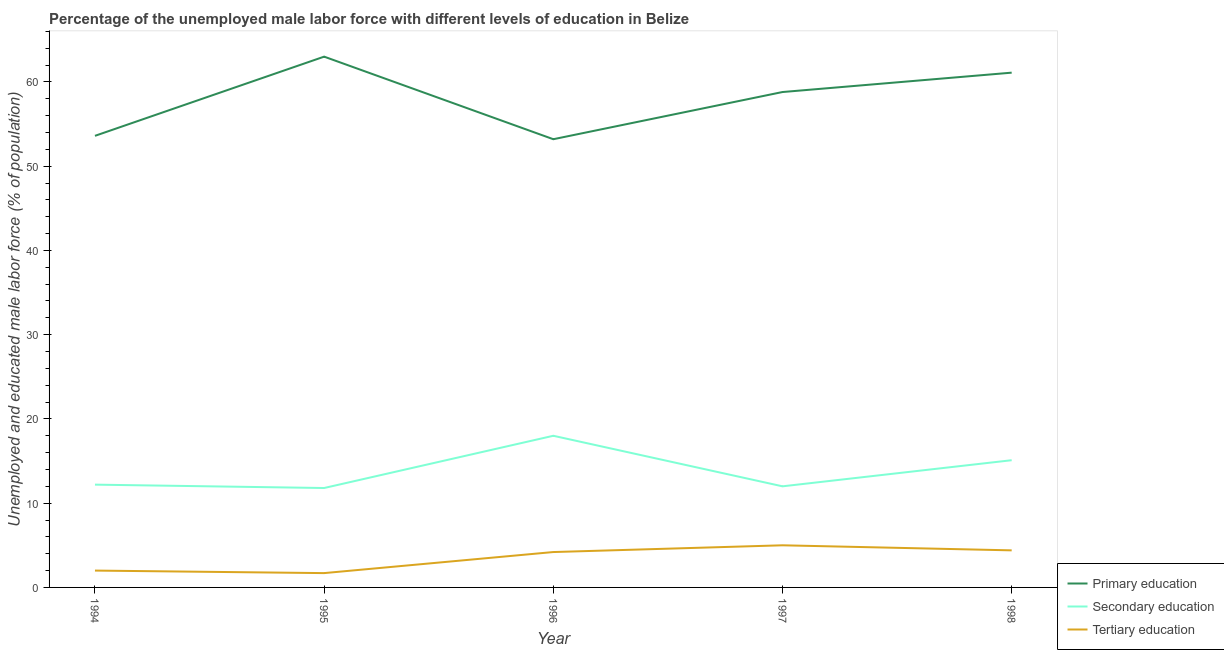What is the percentage of male labor force who received tertiary education in 1996?
Your answer should be compact. 4.2. Across all years, what is the minimum percentage of male labor force who received primary education?
Offer a terse response. 53.2. What is the total percentage of male labor force who received tertiary education in the graph?
Offer a terse response. 17.3. What is the difference between the percentage of male labor force who received primary education in 1995 and that in 1997?
Provide a short and direct response. 4.2. What is the difference between the percentage of male labor force who received tertiary education in 1997 and the percentage of male labor force who received primary education in 1995?
Your response must be concise. -58. What is the average percentage of male labor force who received primary education per year?
Give a very brief answer. 57.94. In the year 1995, what is the difference between the percentage of male labor force who received tertiary education and percentage of male labor force who received primary education?
Your answer should be compact. -61.3. In how many years, is the percentage of male labor force who received secondary education greater than 4 %?
Provide a succinct answer. 5. What is the ratio of the percentage of male labor force who received primary education in 1994 to that in 1997?
Keep it short and to the point. 0.91. Is the difference between the percentage of male labor force who received secondary education in 1996 and 1998 greater than the difference between the percentage of male labor force who received tertiary education in 1996 and 1998?
Offer a terse response. Yes. What is the difference between the highest and the second highest percentage of male labor force who received primary education?
Ensure brevity in your answer.  1.9. What is the difference between the highest and the lowest percentage of male labor force who received primary education?
Your response must be concise. 9.8. Is the sum of the percentage of male labor force who received primary education in 1995 and 1998 greater than the maximum percentage of male labor force who received tertiary education across all years?
Your answer should be compact. Yes. Is the percentage of male labor force who received secondary education strictly less than the percentage of male labor force who received tertiary education over the years?
Make the answer very short. No. How many years are there in the graph?
Provide a short and direct response. 5. What is the difference between two consecutive major ticks on the Y-axis?
Your answer should be very brief. 10. Are the values on the major ticks of Y-axis written in scientific E-notation?
Provide a short and direct response. No. Where does the legend appear in the graph?
Your response must be concise. Bottom right. How are the legend labels stacked?
Offer a very short reply. Vertical. What is the title of the graph?
Offer a terse response. Percentage of the unemployed male labor force with different levels of education in Belize. What is the label or title of the X-axis?
Keep it short and to the point. Year. What is the label or title of the Y-axis?
Provide a succinct answer. Unemployed and educated male labor force (% of population). What is the Unemployed and educated male labor force (% of population) of Primary education in 1994?
Make the answer very short. 53.6. What is the Unemployed and educated male labor force (% of population) of Secondary education in 1994?
Your answer should be very brief. 12.2. What is the Unemployed and educated male labor force (% of population) in Secondary education in 1995?
Provide a succinct answer. 11.8. What is the Unemployed and educated male labor force (% of population) in Tertiary education in 1995?
Your response must be concise. 1.7. What is the Unemployed and educated male labor force (% of population) of Primary education in 1996?
Provide a succinct answer. 53.2. What is the Unemployed and educated male labor force (% of population) in Tertiary education in 1996?
Your answer should be very brief. 4.2. What is the Unemployed and educated male labor force (% of population) in Primary education in 1997?
Ensure brevity in your answer.  58.8. What is the Unemployed and educated male labor force (% of population) of Secondary education in 1997?
Make the answer very short. 12. What is the Unemployed and educated male labor force (% of population) in Primary education in 1998?
Offer a terse response. 61.1. What is the Unemployed and educated male labor force (% of population) in Secondary education in 1998?
Your answer should be compact. 15.1. What is the Unemployed and educated male labor force (% of population) of Tertiary education in 1998?
Your answer should be compact. 4.4. Across all years, what is the maximum Unemployed and educated male labor force (% of population) in Primary education?
Your answer should be compact. 63. Across all years, what is the maximum Unemployed and educated male labor force (% of population) in Tertiary education?
Offer a terse response. 5. Across all years, what is the minimum Unemployed and educated male labor force (% of population) in Primary education?
Give a very brief answer. 53.2. Across all years, what is the minimum Unemployed and educated male labor force (% of population) of Secondary education?
Provide a short and direct response. 11.8. Across all years, what is the minimum Unemployed and educated male labor force (% of population) of Tertiary education?
Make the answer very short. 1.7. What is the total Unemployed and educated male labor force (% of population) of Primary education in the graph?
Provide a succinct answer. 289.7. What is the total Unemployed and educated male labor force (% of population) of Secondary education in the graph?
Ensure brevity in your answer.  69.1. What is the difference between the Unemployed and educated male labor force (% of population) in Secondary education in 1994 and that in 1995?
Give a very brief answer. 0.4. What is the difference between the Unemployed and educated male labor force (% of population) of Tertiary education in 1994 and that in 1995?
Give a very brief answer. 0.3. What is the difference between the Unemployed and educated male labor force (% of population) of Secondary education in 1994 and that in 1997?
Your answer should be compact. 0.2. What is the difference between the Unemployed and educated male labor force (% of population) of Tertiary education in 1994 and that in 1997?
Your answer should be very brief. -3. What is the difference between the Unemployed and educated male labor force (% of population) of Primary education in 1994 and that in 1998?
Provide a short and direct response. -7.5. What is the difference between the Unemployed and educated male labor force (% of population) in Primary education in 1995 and that in 1996?
Offer a terse response. 9.8. What is the difference between the Unemployed and educated male labor force (% of population) of Secondary education in 1995 and that in 1996?
Your response must be concise. -6.2. What is the difference between the Unemployed and educated male labor force (% of population) in Secondary education in 1995 and that in 1997?
Make the answer very short. -0.2. What is the difference between the Unemployed and educated male labor force (% of population) of Tertiary education in 1995 and that in 1998?
Make the answer very short. -2.7. What is the difference between the Unemployed and educated male labor force (% of population) of Primary education in 1996 and that in 1997?
Provide a succinct answer. -5.6. What is the difference between the Unemployed and educated male labor force (% of population) of Primary education in 1996 and that in 1998?
Make the answer very short. -7.9. What is the difference between the Unemployed and educated male labor force (% of population) of Secondary education in 1996 and that in 1998?
Your answer should be compact. 2.9. What is the difference between the Unemployed and educated male labor force (% of population) in Tertiary education in 1996 and that in 1998?
Your answer should be very brief. -0.2. What is the difference between the Unemployed and educated male labor force (% of population) of Primary education in 1997 and that in 1998?
Make the answer very short. -2.3. What is the difference between the Unemployed and educated male labor force (% of population) in Tertiary education in 1997 and that in 1998?
Give a very brief answer. 0.6. What is the difference between the Unemployed and educated male labor force (% of population) in Primary education in 1994 and the Unemployed and educated male labor force (% of population) in Secondary education in 1995?
Ensure brevity in your answer.  41.8. What is the difference between the Unemployed and educated male labor force (% of population) of Primary education in 1994 and the Unemployed and educated male labor force (% of population) of Tertiary education in 1995?
Your answer should be compact. 51.9. What is the difference between the Unemployed and educated male labor force (% of population) of Primary education in 1994 and the Unemployed and educated male labor force (% of population) of Secondary education in 1996?
Your answer should be compact. 35.6. What is the difference between the Unemployed and educated male labor force (% of population) in Primary education in 1994 and the Unemployed and educated male labor force (% of population) in Tertiary education in 1996?
Your answer should be very brief. 49.4. What is the difference between the Unemployed and educated male labor force (% of population) of Primary education in 1994 and the Unemployed and educated male labor force (% of population) of Secondary education in 1997?
Your answer should be very brief. 41.6. What is the difference between the Unemployed and educated male labor force (% of population) in Primary education in 1994 and the Unemployed and educated male labor force (% of population) in Tertiary education in 1997?
Provide a succinct answer. 48.6. What is the difference between the Unemployed and educated male labor force (% of population) in Secondary education in 1994 and the Unemployed and educated male labor force (% of population) in Tertiary education in 1997?
Provide a short and direct response. 7.2. What is the difference between the Unemployed and educated male labor force (% of population) in Primary education in 1994 and the Unemployed and educated male labor force (% of population) in Secondary education in 1998?
Provide a short and direct response. 38.5. What is the difference between the Unemployed and educated male labor force (% of population) of Primary education in 1994 and the Unemployed and educated male labor force (% of population) of Tertiary education in 1998?
Your answer should be very brief. 49.2. What is the difference between the Unemployed and educated male labor force (% of population) in Secondary education in 1994 and the Unemployed and educated male labor force (% of population) in Tertiary education in 1998?
Your response must be concise. 7.8. What is the difference between the Unemployed and educated male labor force (% of population) in Primary education in 1995 and the Unemployed and educated male labor force (% of population) in Tertiary education in 1996?
Provide a short and direct response. 58.8. What is the difference between the Unemployed and educated male labor force (% of population) in Primary education in 1995 and the Unemployed and educated male labor force (% of population) in Secondary education in 1997?
Your answer should be compact. 51. What is the difference between the Unemployed and educated male labor force (% of population) in Primary education in 1995 and the Unemployed and educated male labor force (% of population) in Tertiary education in 1997?
Make the answer very short. 58. What is the difference between the Unemployed and educated male labor force (% of population) of Primary education in 1995 and the Unemployed and educated male labor force (% of population) of Secondary education in 1998?
Offer a very short reply. 47.9. What is the difference between the Unemployed and educated male labor force (% of population) of Primary education in 1995 and the Unemployed and educated male labor force (% of population) of Tertiary education in 1998?
Your response must be concise. 58.6. What is the difference between the Unemployed and educated male labor force (% of population) in Primary education in 1996 and the Unemployed and educated male labor force (% of population) in Secondary education in 1997?
Your response must be concise. 41.2. What is the difference between the Unemployed and educated male labor force (% of population) in Primary education in 1996 and the Unemployed and educated male labor force (% of population) in Tertiary education in 1997?
Your response must be concise. 48.2. What is the difference between the Unemployed and educated male labor force (% of population) in Secondary education in 1996 and the Unemployed and educated male labor force (% of population) in Tertiary education in 1997?
Your response must be concise. 13. What is the difference between the Unemployed and educated male labor force (% of population) of Primary education in 1996 and the Unemployed and educated male labor force (% of population) of Secondary education in 1998?
Your response must be concise. 38.1. What is the difference between the Unemployed and educated male labor force (% of population) of Primary education in 1996 and the Unemployed and educated male labor force (% of population) of Tertiary education in 1998?
Offer a very short reply. 48.8. What is the difference between the Unemployed and educated male labor force (% of population) in Primary education in 1997 and the Unemployed and educated male labor force (% of population) in Secondary education in 1998?
Your response must be concise. 43.7. What is the difference between the Unemployed and educated male labor force (% of population) in Primary education in 1997 and the Unemployed and educated male labor force (% of population) in Tertiary education in 1998?
Your answer should be very brief. 54.4. What is the difference between the Unemployed and educated male labor force (% of population) of Secondary education in 1997 and the Unemployed and educated male labor force (% of population) of Tertiary education in 1998?
Give a very brief answer. 7.6. What is the average Unemployed and educated male labor force (% of population) in Primary education per year?
Give a very brief answer. 57.94. What is the average Unemployed and educated male labor force (% of population) of Secondary education per year?
Keep it short and to the point. 13.82. What is the average Unemployed and educated male labor force (% of population) in Tertiary education per year?
Your response must be concise. 3.46. In the year 1994, what is the difference between the Unemployed and educated male labor force (% of population) of Primary education and Unemployed and educated male labor force (% of population) of Secondary education?
Provide a short and direct response. 41.4. In the year 1994, what is the difference between the Unemployed and educated male labor force (% of population) of Primary education and Unemployed and educated male labor force (% of population) of Tertiary education?
Your answer should be very brief. 51.6. In the year 1995, what is the difference between the Unemployed and educated male labor force (% of population) in Primary education and Unemployed and educated male labor force (% of population) in Secondary education?
Give a very brief answer. 51.2. In the year 1995, what is the difference between the Unemployed and educated male labor force (% of population) in Primary education and Unemployed and educated male labor force (% of population) in Tertiary education?
Your response must be concise. 61.3. In the year 1995, what is the difference between the Unemployed and educated male labor force (% of population) in Secondary education and Unemployed and educated male labor force (% of population) in Tertiary education?
Offer a terse response. 10.1. In the year 1996, what is the difference between the Unemployed and educated male labor force (% of population) of Primary education and Unemployed and educated male labor force (% of population) of Secondary education?
Provide a short and direct response. 35.2. In the year 1996, what is the difference between the Unemployed and educated male labor force (% of population) in Primary education and Unemployed and educated male labor force (% of population) in Tertiary education?
Keep it short and to the point. 49. In the year 1997, what is the difference between the Unemployed and educated male labor force (% of population) of Primary education and Unemployed and educated male labor force (% of population) of Secondary education?
Provide a succinct answer. 46.8. In the year 1997, what is the difference between the Unemployed and educated male labor force (% of population) of Primary education and Unemployed and educated male labor force (% of population) of Tertiary education?
Provide a short and direct response. 53.8. In the year 1997, what is the difference between the Unemployed and educated male labor force (% of population) in Secondary education and Unemployed and educated male labor force (% of population) in Tertiary education?
Make the answer very short. 7. In the year 1998, what is the difference between the Unemployed and educated male labor force (% of population) of Primary education and Unemployed and educated male labor force (% of population) of Tertiary education?
Provide a short and direct response. 56.7. What is the ratio of the Unemployed and educated male labor force (% of population) in Primary education in 1994 to that in 1995?
Give a very brief answer. 0.85. What is the ratio of the Unemployed and educated male labor force (% of population) of Secondary education in 1994 to that in 1995?
Your answer should be very brief. 1.03. What is the ratio of the Unemployed and educated male labor force (% of population) in Tertiary education in 1994 to that in 1995?
Provide a succinct answer. 1.18. What is the ratio of the Unemployed and educated male labor force (% of population) in Primary education in 1994 to that in 1996?
Provide a succinct answer. 1.01. What is the ratio of the Unemployed and educated male labor force (% of population) in Secondary education in 1994 to that in 1996?
Your answer should be compact. 0.68. What is the ratio of the Unemployed and educated male labor force (% of population) in Tertiary education in 1994 to that in 1996?
Ensure brevity in your answer.  0.48. What is the ratio of the Unemployed and educated male labor force (% of population) in Primary education in 1994 to that in 1997?
Your answer should be compact. 0.91. What is the ratio of the Unemployed and educated male labor force (% of population) in Secondary education in 1994 to that in 1997?
Your response must be concise. 1.02. What is the ratio of the Unemployed and educated male labor force (% of population) of Primary education in 1994 to that in 1998?
Your answer should be very brief. 0.88. What is the ratio of the Unemployed and educated male labor force (% of population) of Secondary education in 1994 to that in 1998?
Provide a short and direct response. 0.81. What is the ratio of the Unemployed and educated male labor force (% of population) in Tertiary education in 1994 to that in 1998?
Keep it short and to the point. 0.45. What is the ratio of the Unemployed and educated male labor force (% of population) of Primary education in 1995 to that in 1996?
Provide a succinct answer. 1.18. What is the ratio of the Unemployed and educated male labor force (% of population) of Secondary education in 1995 to that in 1996?
Give a very brief answer. 0.66. What is the ratio of the Unemployed and educated male labor force (% of population) in Tertiary education in 1995 to that in 1996?
Keep it short and to the point. 0.4. What is the ratio of the Unemployed and educated male labor force (% of population) in Primary education in 1995 to that in 1997?
Your response must be concise. 1.07. What is the ratio of the Unemployed and educated male labor force (% of population) in Secondary education in 1995 to that in 1997?
Make the answer very short. 0.98. What is the ratio of the Unemployed and educated male labor force (% of population) in Tertiary education in 1995 to that in 1997?
Offer a very short reply. 0.34. What is the ratio of the Unemployed and educated male labor force (% of population) of Primary education in 1995 to that in 1998?
Make the answer very short. 1.03. What is the ratio of the Unemployed and educated male labor force (% of population) in Secondary education in 1995 to that in 1998?
Keep it short and to the point. 0.78. What is the ratio of the Unemployed and educated male labor force (% of population) of Tertiary education in 1995 to that in 1998?
Give a very brief answer. 0.39. What is the ratio of the Unemployed and educated male labor force (% of population) in Primary education in 1996 to that in 1997?
Provide a succinct answer. 0.9. What is the ratio of the Unemployed and educated male labor force (% of population) of Tertiary education in 1996 to that in 1997?
Provide a short and direct response. 0.84. What is the ratio of the Unemployed and educated male labor force (% of population) of Primary education in 1996 to that in 1998?
Your response must be concise. 0.87. What is the ratio of the Unemployed and educated male labor force (% of population) of Secondary education in 1996 to that in 1998?
Your response must be concise. 1.19. What is the ratio of the Unemployed and educated male labor force (% of population) in Tertiary education in 1996 to that in 1998?
Ensure brevity in your answer.  0.95. What is the ratio of the Unemployed and educated male labor force (% of population) in Primary education in 1997 to that in 1998?
Your answer should be compact. 0.96. What is the ratio of the Unemployed and educated male labor force (% of population) in Secondary education in 1997 to that in 1998?
Give a very brief answer. 0.79. What is the ratio of the Unemployed and educated male labor force (% of population) in Tertiary education in 1997 to that in 1998?
Offer a very short reply. 1.14. What is the difference between the highest and the second highest Unemployed and educated male labor force (% of population) in Primary education?
Provide a succinct answer. 1.9. What is the difference between the highest and the second highest Unemployed and educated male labor force (% of population) in Tertiary education?
Give a very brief answer. 0.6. What is the difference between the highest and the lowest Unemployed and educated male labor force (% of population) in Primary education?
Keep it short and to the point. 9.8. What is the difference between the highest and the lowest Unemployed and educated male labor force (% of population) of Secondary education?
Offer a terse response. 6.2. 